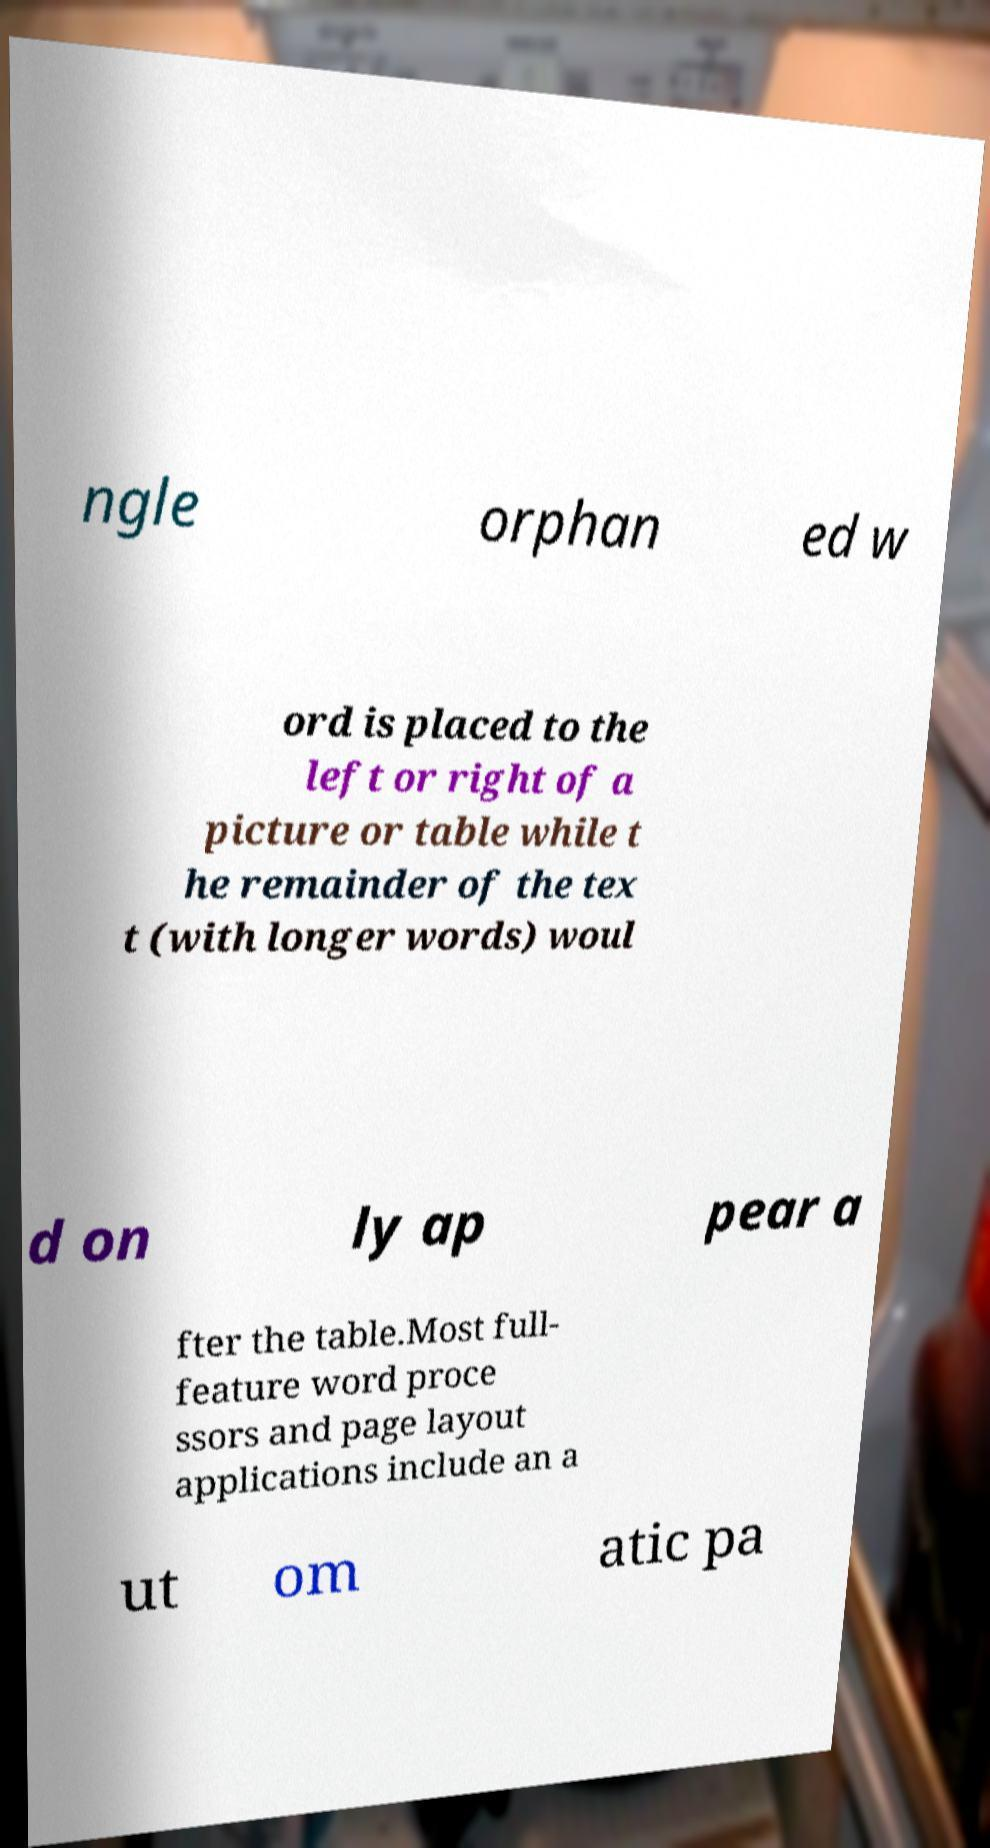I need the written content from this picture converted into text. Can you do that? ngle orphan ed w ord is placed to the left or right of a picture or table while t he remainder of the tex t (with longer words) woul d on ly ap pear a fter the table.Most full- feature word proce ssors and page layout applications include an a ut om atic pa 